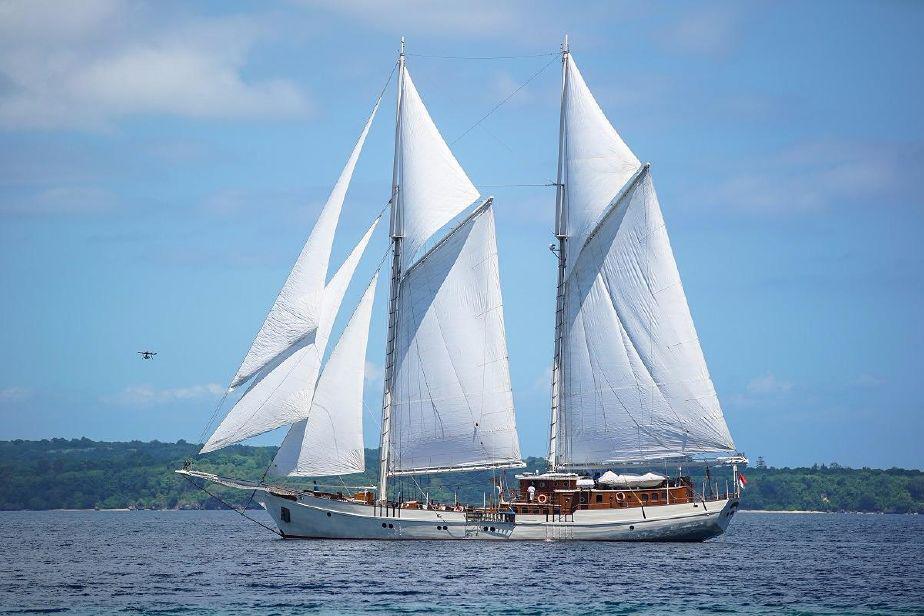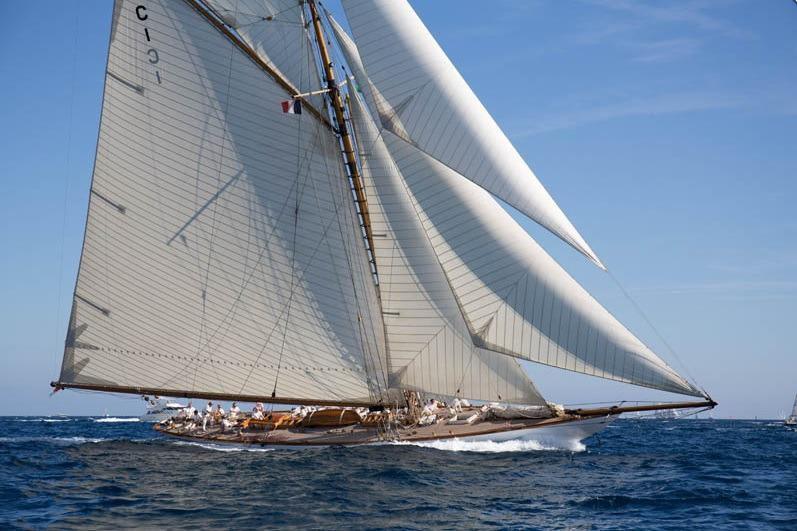The first image is the image on the left, the second image is the image on the right. Given the left and right images, does the statement "The two boats are heading towards each other." hold true? Answer yes or no. No. The first image is the image on the left, the second image is the image on the right. Given the left and right images, does the statement "There are two white sailboats on the water." hold true? Answer yes or no. Yes. 